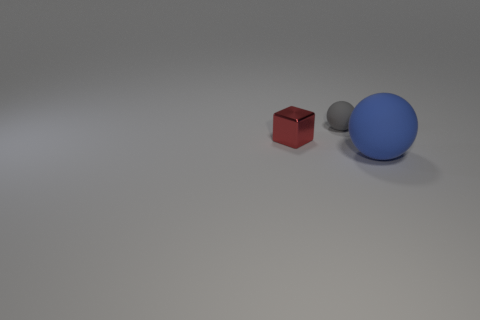If this were a scene from a story, what genre do you think it might represent? Given its simplicity and the ambiguity of its elements, the scene could represent a moment in a sci-fi or a psychological drama where objects may hold symbolic significance or are placed in a way that provokes thought or speculation. 